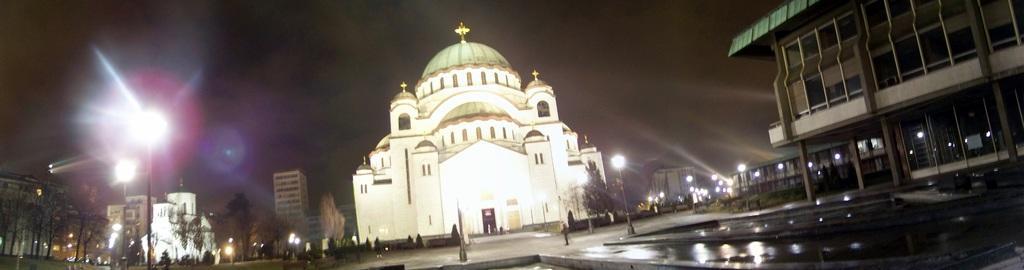Please provide a concise description of this image. In this image there are few street lights are on the pavement. Few persons are on the road. There are few trees. Behind there are few buildings. Top of image there is sky. Few branches are on the grassland. 